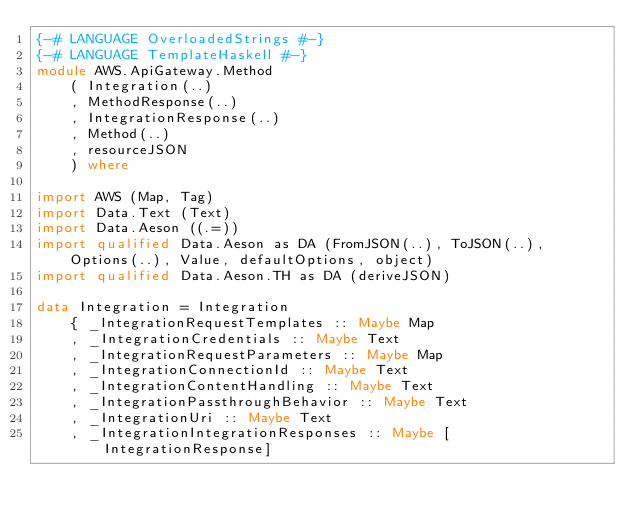Convert code to text. <code><loc_0><loc_0><loc_500><loc_500><_Haskell_>{-# LANGUAGE OverloadedStrings #-}
{-# LANGUAGE TemplateHaskell #-}
module AWS.ApiGateway.Method
    ( Integration(..)
    , MethodResponse(..)
    , IntegrationResponse(..)
    , Method(..)
    , resourceJSON
    ) where

import AWS (Map, Tag)
import Data.Text (Text)
import Data.Aeson ((.=))
import qualified Data.Aeson as DA (FromJSON(..), ToJSON(..), Options(..), Value, defaultOptions, object)
import qualified Data.Aeson.TH as DA (deriveJSON)

data Integration = Integration
    { _IntegrationRequestTemplates :: Maybe Map
    , _IntegrationCredentials :: Maybe Text
    , _IntegrationRequestParameters :: Maybe Map
    , _IntegrationConnectionId :: Maybe Text
    , _IntegrationContentHandling :: Maybe Text
    , _IntegrationPassthroughBehavior :: Maybe Text
    , _IntegrationUri :: Maybe Text
    , _IntegrationIntegrationResponses :: Maybe [IntegrationResponse]</code> 